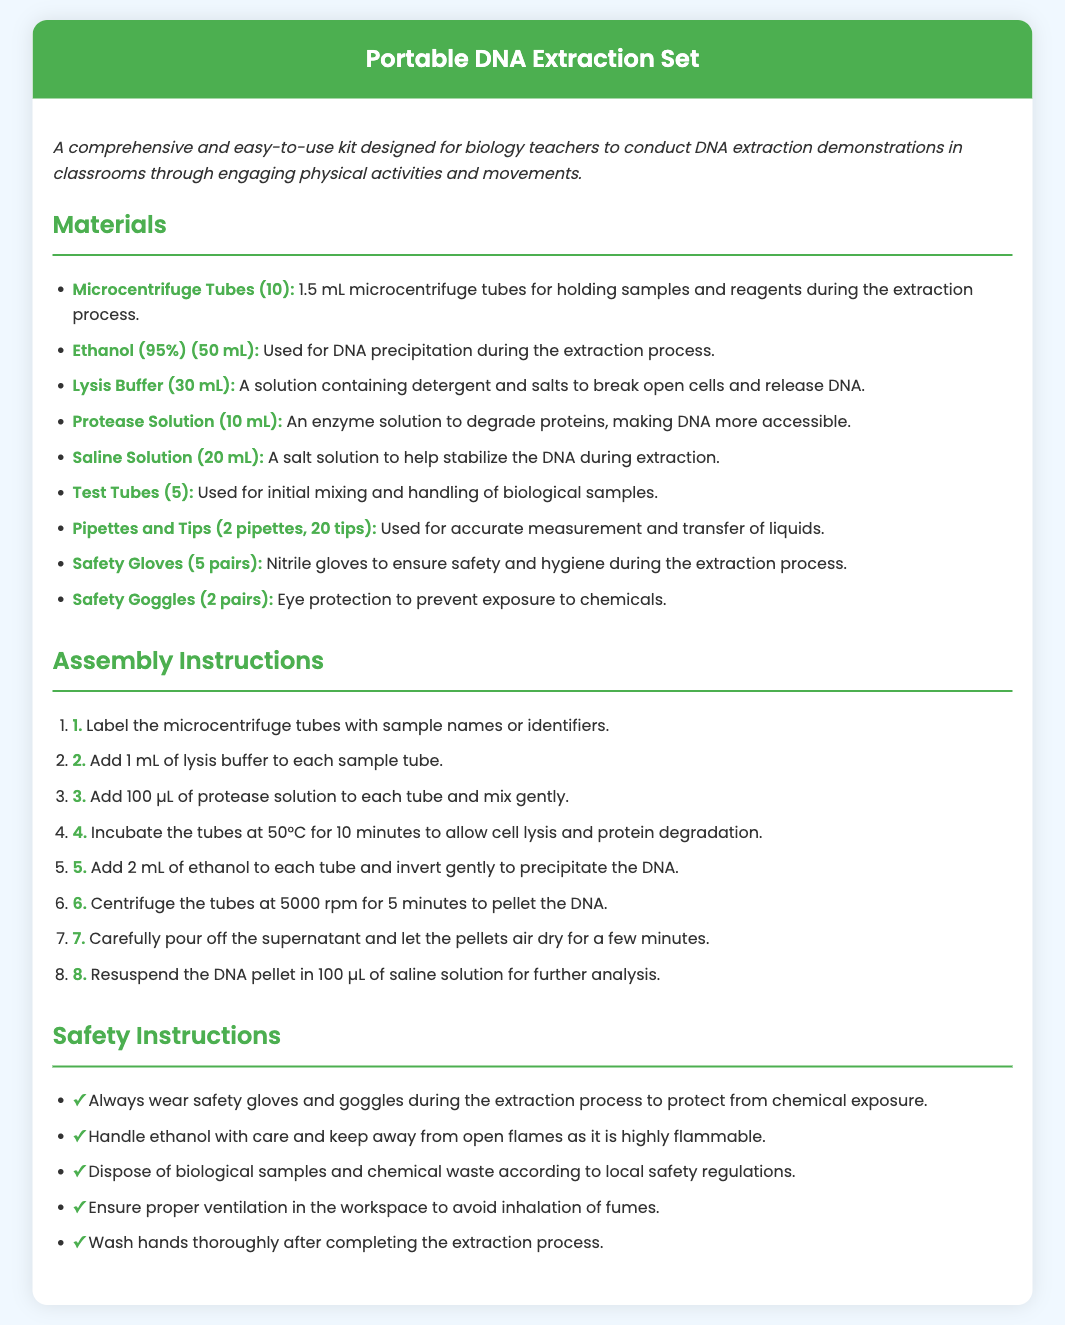What is the volume of ethanol included? The document specifies the amount of ethanol provided in the kit, which is 50 mL.
Answer: 50 mL How many microcentrifuge tubes are provided? The total number of microcentrifuge tubes listed in the materials section of the document is 10.
Answer: 10 What is the purpose of the lysis buffer? The document explains that the lysis buffer breaks open cells and releases DNA.
Answer: Break open cells What step involves adding ethanol? The assembly instructions say that ethanol is added in step 5.
Answer: Step 5 What type of gloves are included in the kit? The materials section mentions that nitrile gloves are included for safety.
Answer: Nitrile gloves What is the centrifugation speed mentioned? The assembly instructions indicate that the centrifugation should be done at 5000 rpm.
Answer: 5000 rpm What should you do after completing the extraction process? The safety section advises to wash hands thoroughly after the extraction process.
Answer: Wash hands How many pairs of safety goggles are provided? The document states that there are 2 pairs of safety goggles included in the set.
Answer: 2 pairs What temperature should the tubes be incubated at? The assembly instructions specify an incubation temperature of 50°C for the tubes.
Answer: 50°C 